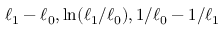Convert formula to latex. <formula><loc_0><loc_0><loc_500><loc_500>\ell _ { 1 } - \ell _ { 0 } , \ln ( \ell _ { 1 } / \ell _ { 0 } ) , 1 / \ell _ { 0 } - 1 / \ell _ { 1 }</formula> 